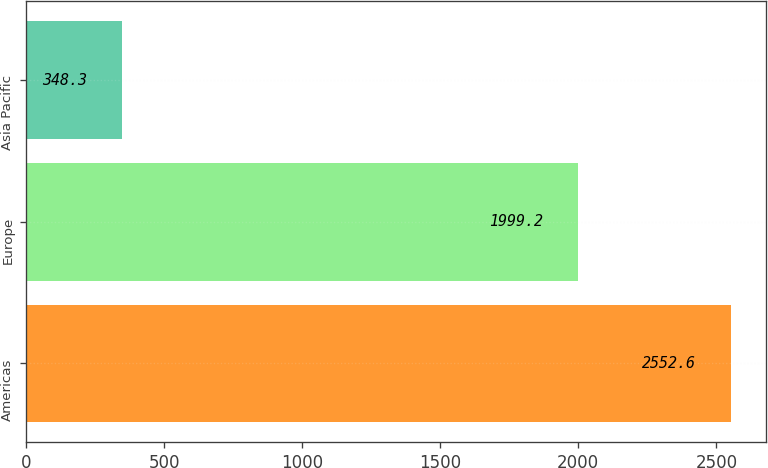Convert chart. <chart><loc_0><loc_0><loc_500><loc_500><bar_chart><fcel>Americas<fcel>Europe<fcel>Asia Pacific<nl><fcel>2552.6<fcel>1999.2<fcel>348.3<nl></chart> 